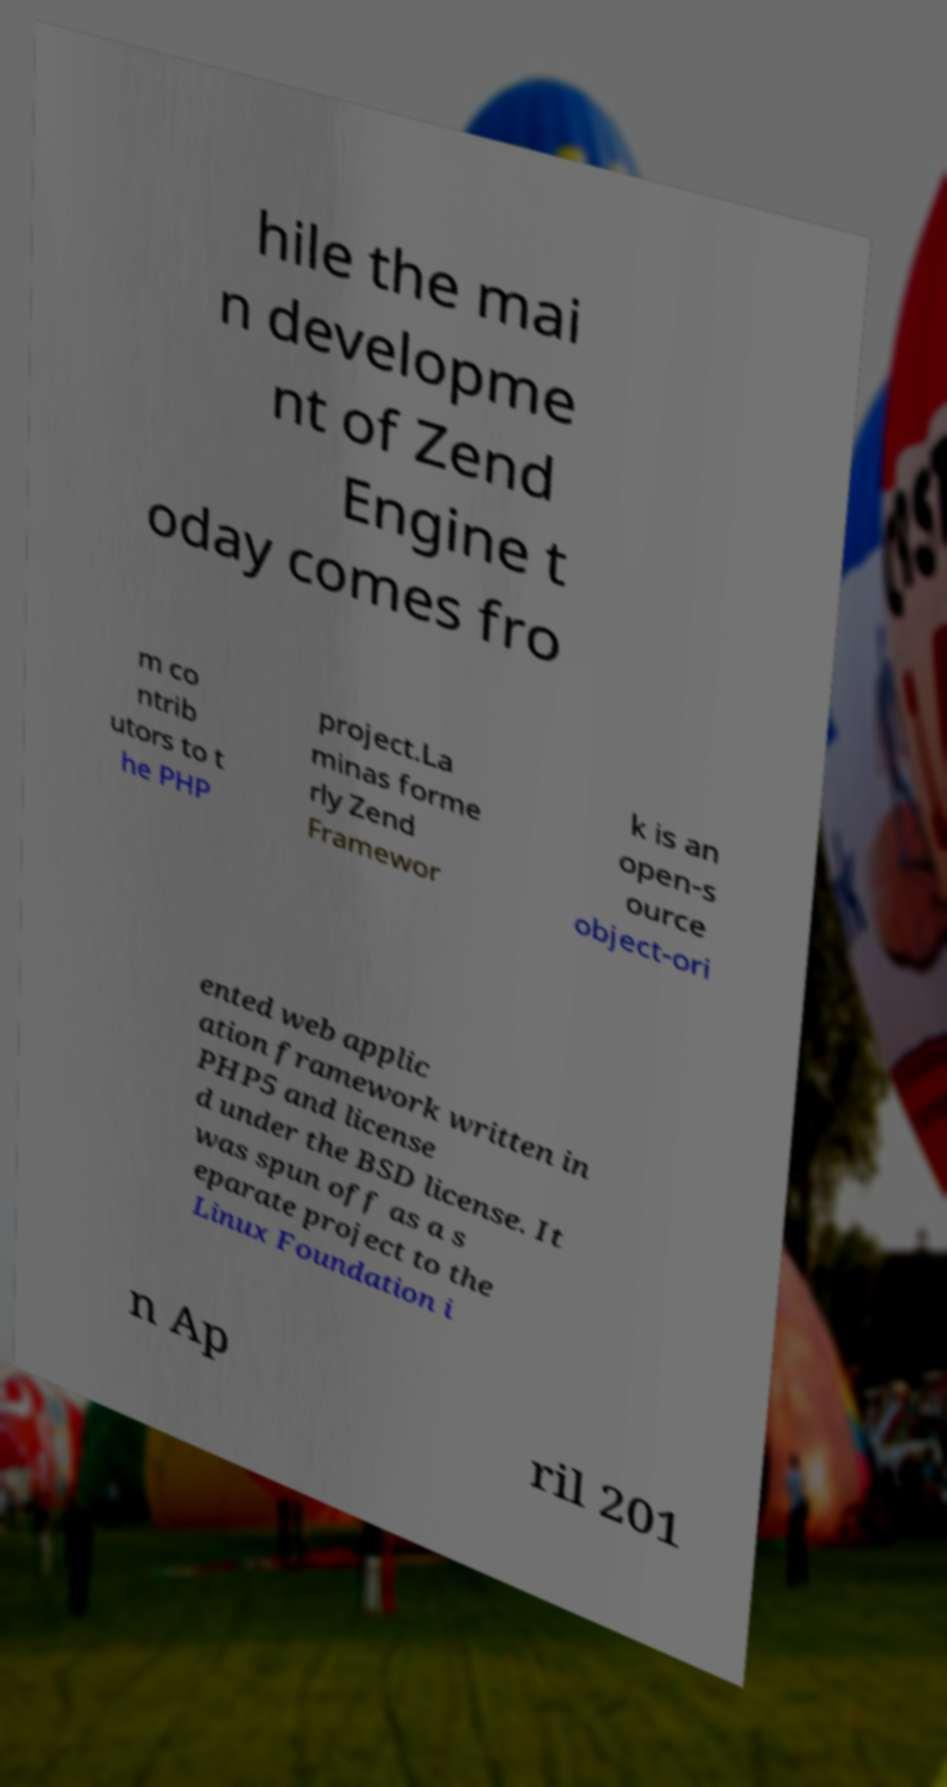Could you assist in decoding the text presented in this image and type it out clearly? hile the mai n developme nt of Zend Engine t oday comes fro m co ntrib utors to t he PHP project.La minas forme rly Zend Framewor k is an open-s ource object-ori ented web applic ation framework written in PHP5 and license d under the BSD license. It was spun off as a s eparate project to the Linux Foundation i n Ap ril 201 